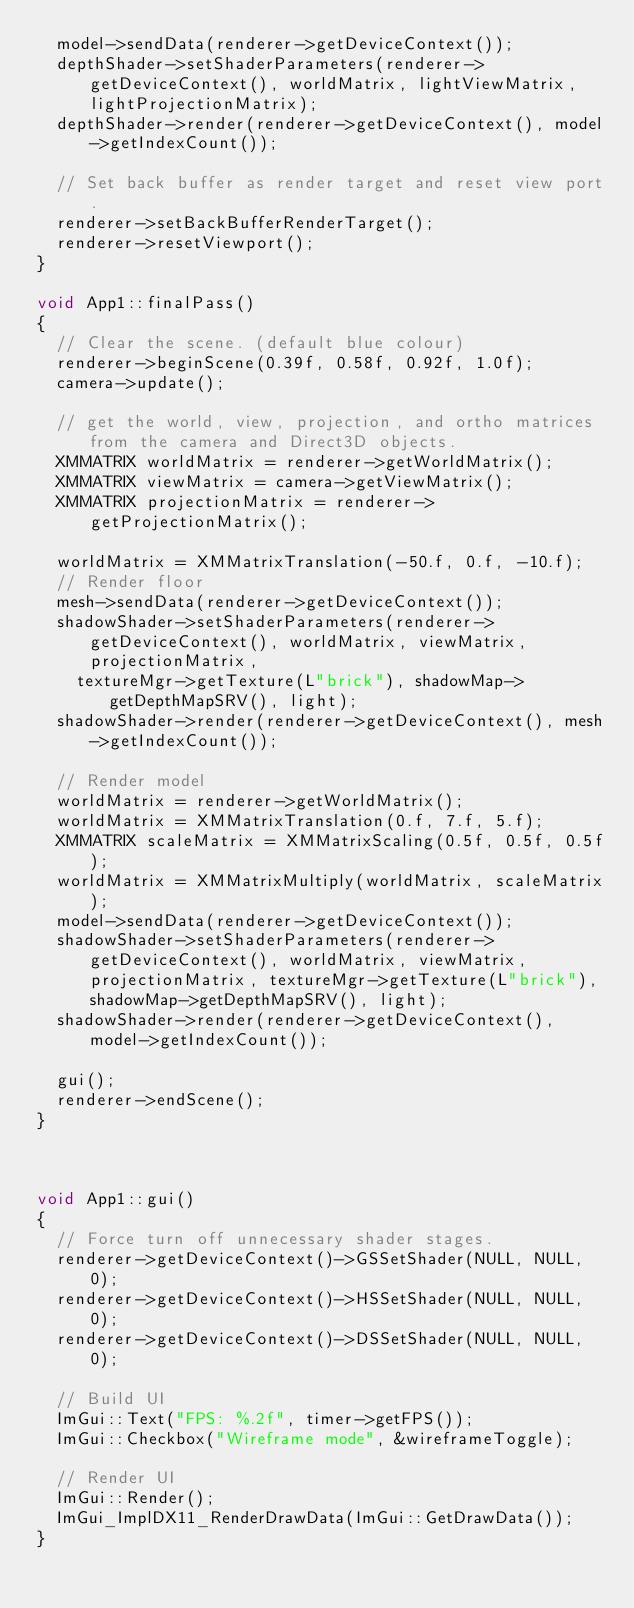Convert code to text. <code><loc_0><loc_0><loc_500><loc_500><_C++_>	model->sendData(renderer->getDeviceContext());
	depthShader->setShaderParameters(renderer->getDeviceContext(), worldMatrix, lightViewMatrix, lightProjectionMatrix);
	depthShader->render(renderer->getDeviceContext(), model->getIndexCount());

	// Set back buffer as render target and reset view port.
	renderer->setBackBufferRenderTarget();
	renderer->resetViewport();
}

void App1::finalPass()
{
	// Clear the scene. (default blue colour)
	renderer->beginScene(0.39f, 0.58f, 0.92f, 1.0f);
	camera->update();

	// get the world, view, projection, and ortho matrices from the camera and Direct3D objects.
	XMMATRIX worldMatrix = renderer->getWorldMatrix();
	XMMATRIX viewMatrix = camera->getViewMatrix();
	XMMATRIX projectionMatrix = renderer->getProjectionMatrix();

	worldMatrix = XMMatrixTranslation(-50.f, 0.f, -10.f);
	// Render floor
	mesh->sendData(renderer->getDeviceContext());
	shadowShader->setShaderParameters(renderer->getDeviceContext(), worldMatrix, viewMatrix, projectionMatrix, 
		textureMgr->getTexture(L"brick"), shadowMap->getDepthMapSRV(), light);
	shadowShader->render(renderer->getDeviceContext(), mesh->getIndexCount());

	// Render model
	worldMatrix = renderer->getWorldMatrix();
	worldMatrix = XMMatrixTranslation(0.f, 7.f, 5.f);
	XMMATRIX scaleMatrix = XMMatrixScaling(0.5f, 0.5f, 0.5f);
	worldMatrix = XMMatrixMultiply(worldMatrix, scaleMatrix);
	model->sendData(renderer->getDeviceContext());
	shadowShader->setShaderParameters(renderer->getDeviceContext(), worldMatrix, viewMatrix, projectionMatrix, textureMgr->getTexture(L"brick"), shadowMap->getDepthMapSRV(), light);
	shadowShader->render(renderer->getDeviceContext(), model->getIndexCount());

	gui();
	renderer->endScene();
}



void App1::gui()
{
	// Force turn off unnecessary shader stages.
	renderer->getDeviceContext()->GSSetShader(NULL, NULL, 0);
	renderer->getDeviceContext()->HSSetShader(NULL, NULL, 0);
	renderer->getDeviceContext()->DSSetShader(NULL, NULL, 0);

	// Build UI
	ImGui::Text("FPS: %.2f", timer->getFPS());
	ImGui::Checkbox("Wireframe mode", &wireframeToggle);

	// Render UI
	ImGui::Render();
	ImGui_ImplDX11_RenderDrawData(ImGui::GetDrawData());
}

</code> 